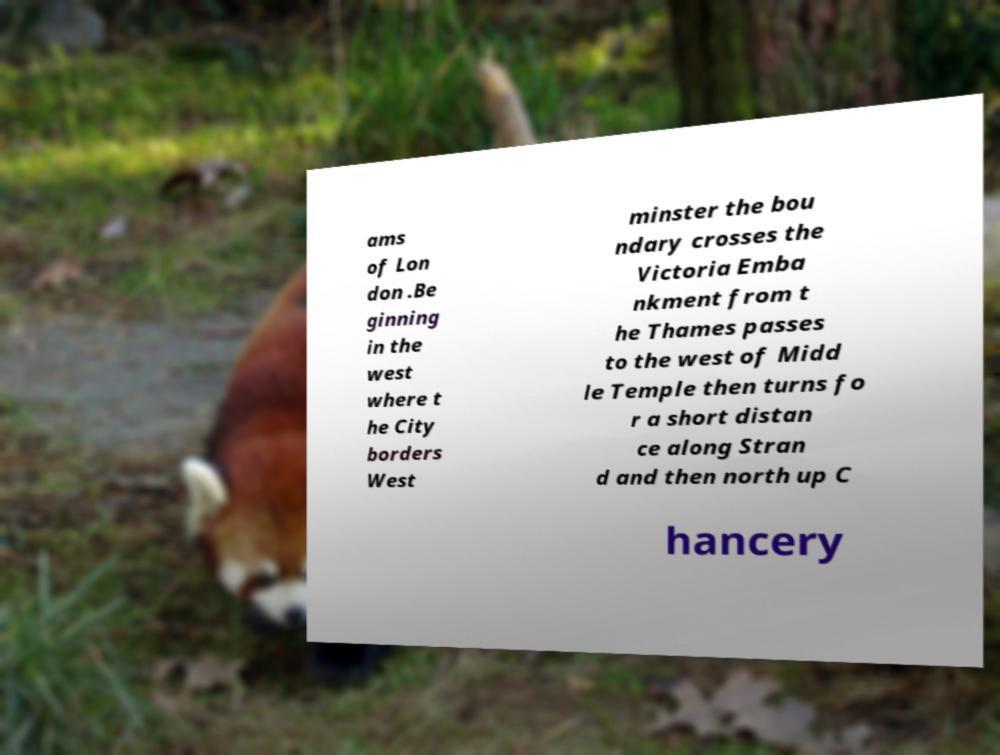For documentation purposes, I need the text within this image transcribed. Could you provide that? ams of Lon don .Be ginning in the west where t he City borders West minster the bou ndary crosses the Victoria Emba nkment from t he Thames passes to the west of Midd le Temple then turns fo r a short distan ce along Stran d and then north up C hancery 